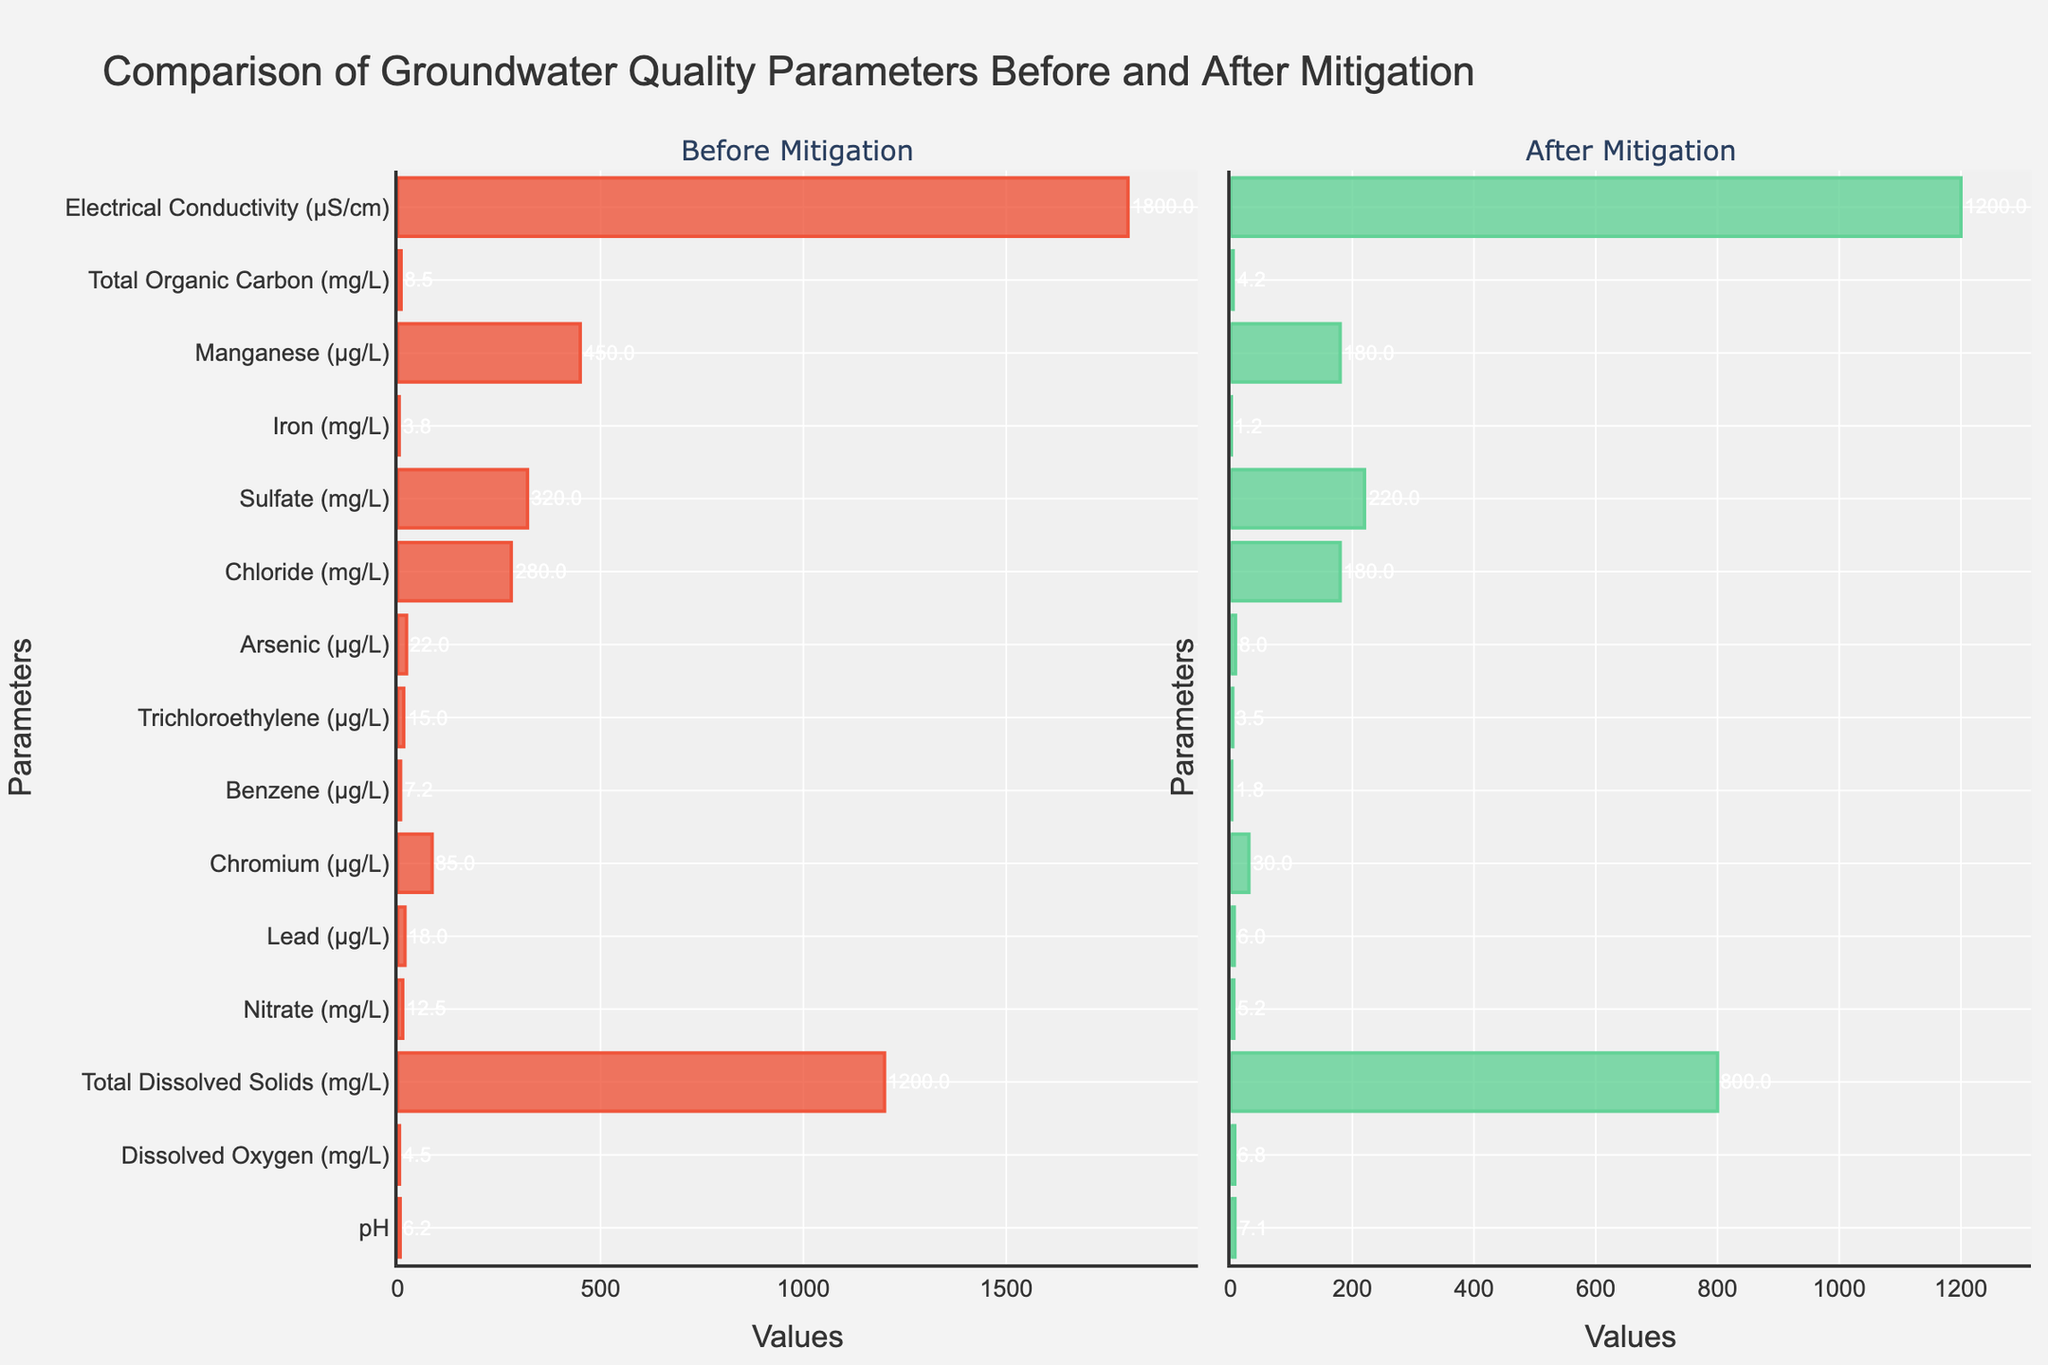which parameter shows the largest absolute improvement after mitigation? Calculate the difference for each parameter between before and after mitigation, Absolute difference = Before - After. Then, find the maximum value among these differences. The parameters and their differences are: pH=0.9, Dissolved Oxygen=2.3, Total Dissolved Solids=400, Nitrate=7.3, Lead=12, Chromium=55, Benzene=5.4, Trichloroethylene=11.5, Arsenic=14, Chloride=100, Sulfate=100, Iron=2.6, Manganese=270, Total Organic Carbon=4.3, Electrical Conductivity=600. The largest difference is for Electrical Conductivity, which decreased by 600 µS/cm
Answer: Electrical Conductivity What is the average value of 'Nitrate' and 'Lead' after mitigation? First, find the values of 'Nitrate' and 'Lead' after mitigation, which are 5.2 and 6 µg/L, respectively. Sum these values and then divide by 2 to get the average value. (5.2 + 6) / 2 = 5.6 µg/L
Answer: 5.6 µg/L Which parameter exhibited the least change after mitigation? Calculate the absolute difference for each parameter (Before - After). The parameter with the smallest absolute difference is the one with the least change. Analyzing the data: pH=0.9, Dissolved Oxygen=2.3, Total Dissolved Solids=400, Nitrate=7.3, Lead=12, Chromium=55, Benzene=5.4, Trichloroethylene=11.5, Arsenic=14, Chloride=100, Sulfate=100, Iron=2.6, Manganese=270, Total Organic Carbon=4.3, Electrical Conductivity=600. The least change observed is in pH, with a difference of 0.9 pH units
Answer: pH How much did the 'Iron' concentration decrease after mitigation? Find the 'Iron' concentration before mitigation (3.8 mg/L) and after mitigation (1.2 mg/L). Subtract the after value from the before value to get the decrease: 3.8 - 1.2 = 2.6 mg/L
Answer: 2.6 mg/L Which parameters had a reduction to less than half their initial value after mitigation? Compare the 'Before' and 'After' values for all parameters to see if the 'After' value is less than half the 'Before' value: Calculations -
pH: 7.1 is not < 3.1
Dissolved Oxygen: 6.8 is not < 2.25
Total Dissolved Solids: 800 is not < 600
Nitrate: 5.2 < 6.25 (Yes)
Lead: 6 < 9 (Yes)
Chromium: 30 < 42.5 (Yes)
Benzene: 1.8 < 3.6 (Yes)
Trichloroethylene: 3.5 < 7.5 (Yes)
Arsenic: 8 < 11 (Yes)
Chloride: 180 < 140 (No)
Sulfate: 220 < 160 (No)
Iron: 1.2 < 1.9 (Yes)
Manganese: 180 < 225 (Yes)
Total Organic Carbon: 4.2 < 4.25 (Yes)
Electrical Conductivity: 1200 < 900 (No)
The parameters are: Nitrate, Lead, Chromium, Benzene, Trichloroethylene, Arsenic, Iron, Manganese, Total Organic Carbon
Answer: Nitrate, Lead, Chromium, Benzene, Trichloroethylene, Arsenic, Iron, Manganese, Total Organic Carbon 